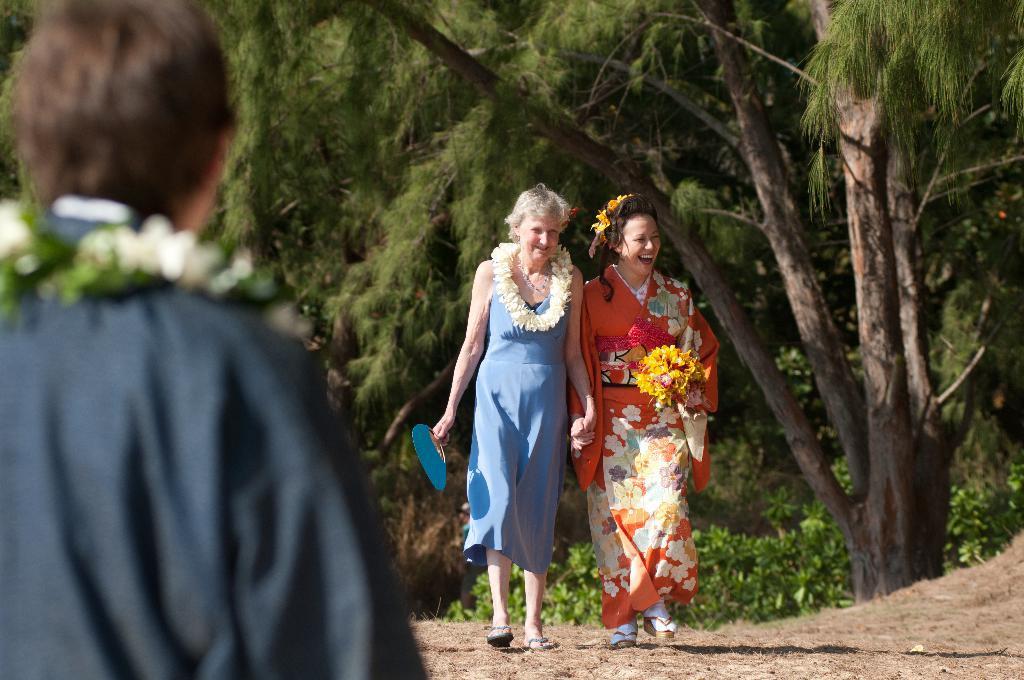In one or two sentences, can you explain what this image depicts? In the middle of the image we can see two women are walking on the ground and they are smiling. In the background we can see plants and trees. On the left side of the image we can see a person who is truncated. 